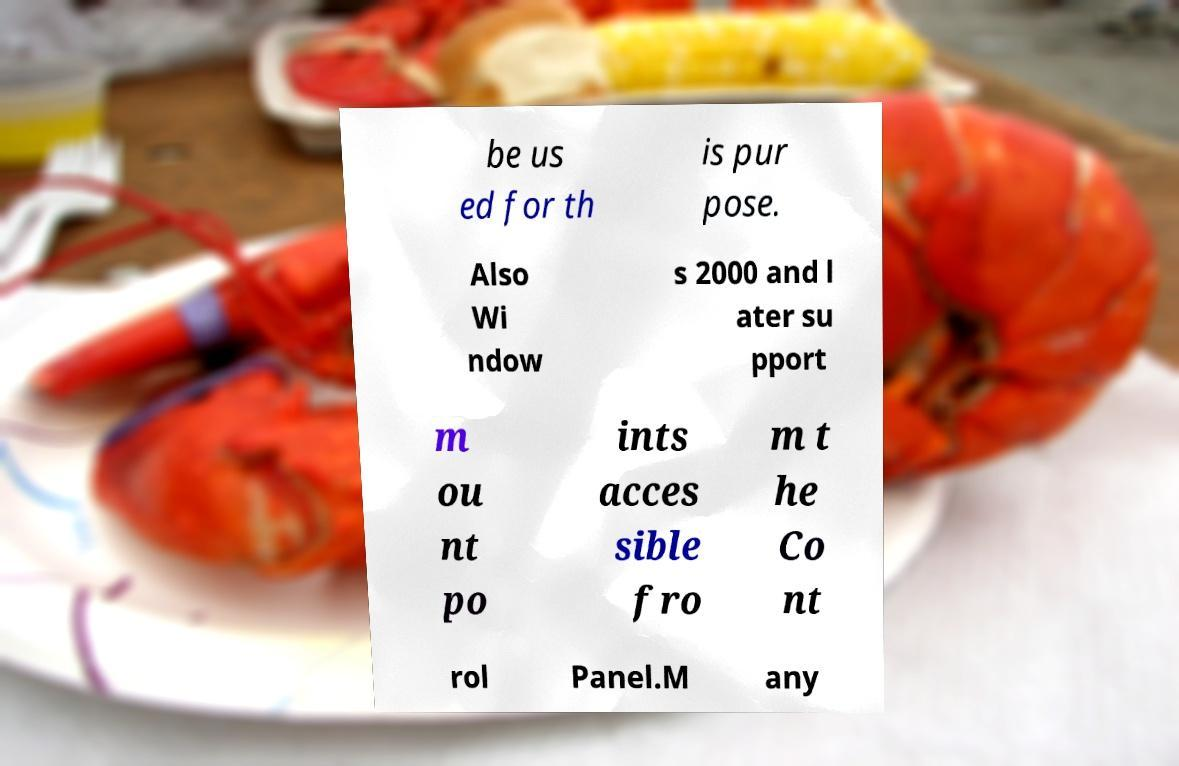For documentation purposes, I need the text within this image transcribed. Could you provide that? be us ed for th is pur pose. Also Wi ndow s 2000 and l ater su pport m ou nt po ints acces sible fro m t he Co nt rol Panel.M any 